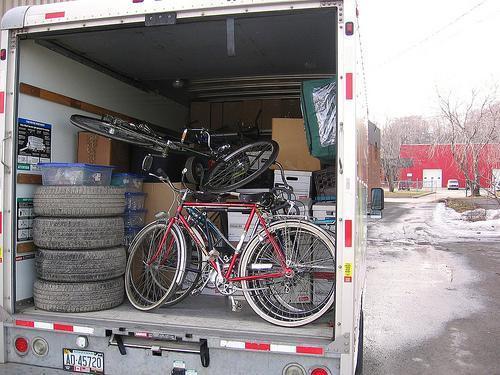How many people are riding bike in the truck?
Give a very brief answer. 0. 